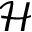<formula> <loc_0><loc_0><loc_500><loc_500>\mathcal { H }</formula> 